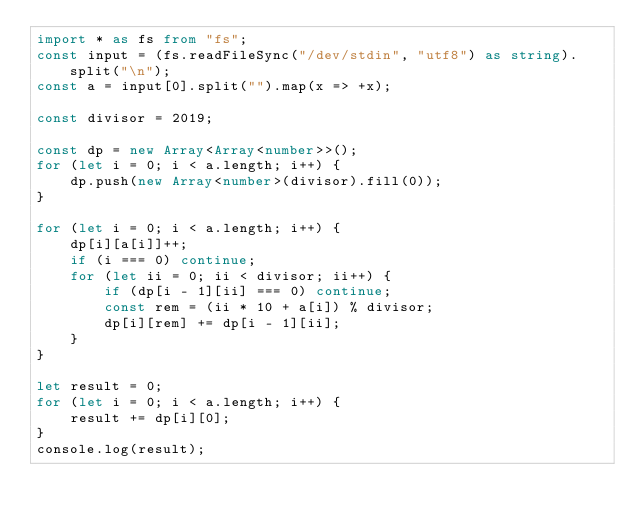Convert code to text. <code><loc_0><loc_0><loc_500><loc_500><_TypeScript_>import * as fs from "fs";
const input = (fs.readFileSync("/dev/stdin", "utf8") as string).split("\n");
const a = input[0].split("").map(x => +x);

const divisor = 2019;

const dp = new Array<Array<number>>();
for (let i = 0; i < a.length; i++) {
	dp.push(new Array<number>(divisor).fill(0));
}

for (let i = 0; i < a.length; i++) {
	dp[i][a[i]]++;
	if (i === 0) continue;
	for (let ii = 0; ii < divisor; ii++) {
		if (dp[i - 1][ii] === 0) continue;
		const rem = (ii * 10 + a[i]) % divisor;
		dp[i][rem] += dp[i - 1][ii];
	}
}

let result = 0;
for (let i = 0; i < a.length; i++) {
	result += dp[i][0];
}
console.log(result);
</code> 